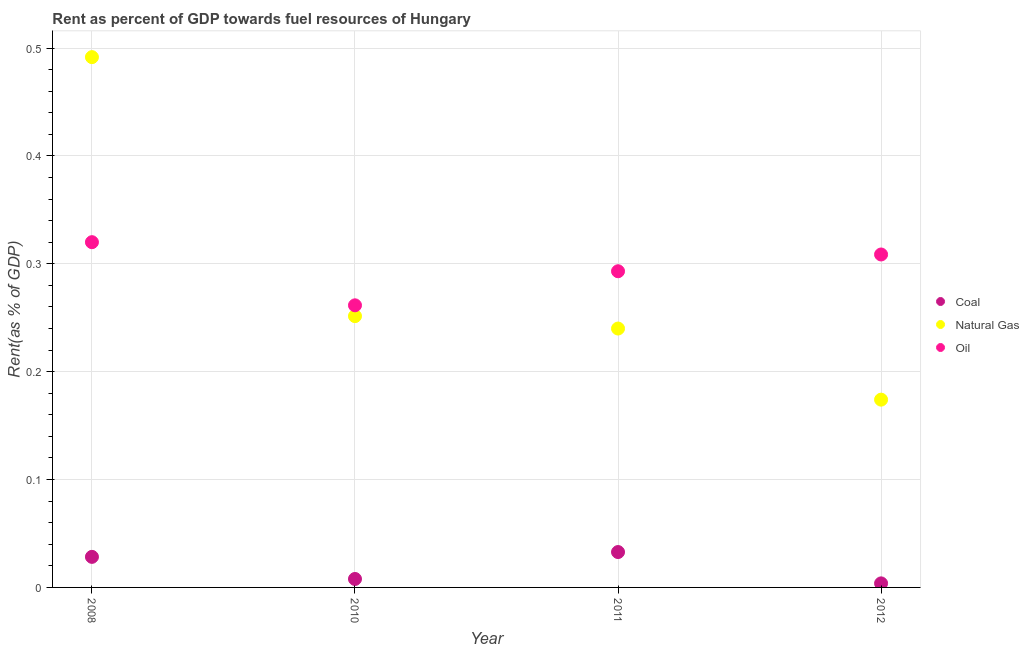Is the number of dotlines equal to the number of legend labels?
Provide a short and direct response. Yes. What is the rent towards oil in 2010?
Make the answer very short. 0.26. Across all years, what is the maximum rent towards coal?
Provide a short and direct response. 0.03. Across all years, what is the minimum rent towards natural gas?
Your answer should be very brief. 0.17. What is the total rent towards coal in the graph?
Keep it short and to the point. 0.07. What is the difference between the rent towards natural gas in 2008 and that in 2012?
Make the answer very short. 0.32. What is the difference between the rent towards coal in 2012 and the rent towards natural gas in 2008?
Your answer should be compact. -0.49. What is the average rent towards natural gas per year?
Your answer should be compact. 0.29. In the year 2011, what is the difference between the rent towards oil and rent towards coal?
Ensure brevity in your answer.  0.26. What is the ratio of the rent towards oil in 2008 to that in 2012?
Offer a terse response. 1.04. Is the rent towards oil in 2011 less than that in 2012?
Make the answer very short. Yes. What is the difference between the highest and the second highest rent towards natural gas?
Provide a succinct answer. 0.24. What is the difference between the highest and the lowest rent towards oil?
Provide a short and direct response. 0.06. Is the rent towards coal strictly less than the rent towards oil over the years?
Your answer should be very brief. Yes. How many dotlines are there?
Ensure brevity in your answer.  3. What is the difference between two consecutive major ticks on the Y-axis?
Give a very brief answer. 0.1. Does the graph contain any zero values?
Your answer should be compact. No. What is the title of the graph?
Your answer should be very brief. Rent as percent of GDP towards fuel resources of Hungary. Does "Natural Gas" appear as one of the legend labels in the graph?
Make the answer very short. Yes. What is the label or title of the Y-axis?
Provide a succinct answer. Rent(as % of GDP). What is the Rent(as % of GDP) of Coal in 2008?
Provide a succinct answer. 0.03. What is the Rent(as % of GDP) of Natural Gas in 2008?
Keep it short and to the point. 0.49. What is the Rent(as % of GDP) in Oil in 2008?
Provide a succinct answer. 0.32. What is the Rent(as % of GDP) of Coal in 2010?
Offer a very short reply. 0.01. What is the Rent(as % of GDP) in Natural Gas in 2010?
Offer a very short reply. 0.25. What is the Rent(as % of GDP) of Oil in 2010?
Your answer should be compact. 0.26. What is the Rent(as % of GDP) of Coal in 2011?
Offer a terse response. 0.03. What is the Rent(as % of GDP) of Natural Gas in 2011?
Your answer should be very brief. 0.24. What is the Rent(as % of GDP) of Oil in 2011?
Make the answer very short. 0.29. What is the Rent(as % of GDP) in Coal in 2012?
Ensure brevity in your answer.  0. What is the Rent(as % of GDP) in Natural Gas in 2012?
Keep it short and to the point. 0.17. What is the Rent(as % of GDP) in Oil in 2012?
Your response must be concise. 0.31. Across all years, what is the maximum Rent(as % of GDP) of Coal?
Give a very brief answer. 0.03. Across all years, what is the maximum Rent(as % of GDP) in Natural Gas?
Give a very brief answer. 0.49. Across all years, what is the maximum Rent(as % of GDP) of Oil?
Your answer should be very brief. 0.32. Across all years, what is the minimum Rent(as % of GDP) in Coal?
Your answer should be very brief. 0. Across all years, what is the minimum Rent(as % of GDP) of Natural Gas?
Your response must be concise. 0.17. Across all years, what is the minimum Rent(as % of GDP) of Oil?
Offer a very short reply. 0.26. What is the total Rent(as % of GDP) of Coal in the graph?
Ensure brevity in your answer.  0.07. What is the total Rent(as % of GDP) of Natural Gas in the graph?
Your answer should be compact. 1.16. What is the total Rent(as % of GDP) of Oil in the graph?
Your answer should be compact. 1.18. What is the difference between the Rent(as % of GDP) in Coal in 2008 and that in 2010?
Offer a terse response. 0.02. What is the difference between the Rent(as % of GDP) in Natural Gas in 2008 and that in 2010?
Keep it short and to the point. 0.24. What is the difference between the Rent(as % of GDP) of Oil in 2008 and that in 2010?
Your answer should be very brief. 0.06. What is the difference between the Rent(as % of GDP) in Coal in 2008 and that in 2011?
Offer a very short reply. -0. What is the difference between the Rent(as % of GDP) in Natural Gas in 2008 and that in 2011?
Your answer should be compact. 0.25. What is the difference between the Rent(as % of GDP) of Oil in 2008 and that in 2011?
Keep it short and to the point. 0.03. What is the difference between the Rent(as % of GDP) in Coal in 2008 and that in 2012?
Make the answer very short. 0.02. What is the difference between the Rent(as % of GDP) in Natural Gas in 2008 and that in 2012?
Offer a very short reply. 0.32. What is the difference between the Rent(as % of GDP) in Oil in 2008 and that in 2012?
Offer a very short reply. 0.01. What is the difference between the Rent(as % of GDP) of Coal in 2010 and that in 2011?
Offer a terse response. -0.03. What is the difference between the Rent(as % of GDP) of Natural Gas in 2010 and that in 2011?
Give a very brief answer. 0.01. What is the difference between the Rent(as % of GDP) in Oil in 2010 and that in 2011?
Make the answer very short. -0.03. What is the difference between the Rent(as % of GDP) of Coal in 2010 and that in 2012?
Your response must be concise. 0. What is the difference between the Rent(as % of GDP) of Natural Gas in 2010 and that in 2012?
Provide a succinct answer. 0.08. What is the difference between the Rent(as % of GDP) in Oil in 2010 and that in 2012?
Your response must be concise. -0.05. What is the difference between the Rent(as % of GDP) in Coal in 2011 and that in 2012?
Provide a short and direct response. 0.03. What is the difference between the Rent(as % of GDP) in Natural Gas in 2011 and that in 2012?
Your answer should be very brief. 0.07. What is the difference between the Rent(as % of GDP) of Oil in 2011 and that in 2012?
Provide a short and direct response. -0.02. What is the difference between the Rent(as % of GDP) in Coal in 2008 and the Rent(as % of GDP) in Natural Gas in 2010?
Your response must be concise. -0.22. What is the difference between the Rent(as % of GDP) of Coal in 2008 and the Rent(as % of GDP) of Oil in 2010?
Make the answer very short. -0.23. What is the difference between the Rent(as % of GDP) in Natural Gas in 2008 and the Rent(as % of GDP) in Oil in 2010?
Provide a succinct answer. 0.23. What is the difference between the Rent(as % of GDP) in Coal in 2008 and the Rent(as % of GDP) in Natural Gas in 2011?
Make the answer very short. -0.21. What is the difference between the Rent(as % of GDP) of Coal in 2008 and the Rent(as % of GDP) of Oil in 2011?
Provide a short and direct response. -0.26. What is the difference between the Rent(as % of GDP) of Natural Gas in 2008 and the Rent(as % of GDP) of Oil in 2011?
Your answer should be very brief. 0.2. What is the difference between the Rent(as % of GDP) of Coal in 2008 and the Rent(as % of GDP) of Natural Gas in 2012?
Give a very brief answer. -0.15. What is the difference between the Rent(as % of GDP) in Coal in 2008 and the Rent(as % of GDP) in Oil in 2012?
Ensure brevity in your answer.  -0.28. What is the difference between the Rent(as % of GDP) of Natural Gas in 2008 and the Rent(as % of GDP) of Oil in 2012?
Offer a terse response. 0.18. What is the difference between the Rent(as % of GDP) of Coal in 2010 and the Rent(as % of GDP) of Natural Gas in 2011?
Your response must be concise. -0.23. What is the difference between the Rent(as % of GDP) of Coal in 2010 and the Rent(as % of GDP) of Oil in 2011?
Offer a very short reply. -0.29. What is the difference between the Rent(as % of GDP) of Natural Gas in 2010 and the Rent(as % of GDP) of Oil in 2011?
Give a very brief answer. -0.04. What is the difference between the Rent(as % of GDP) in Coal in 2010 and the Rent(as % of GDP) in Natural Gas in 2012?
Offer a very short reply. -0.17. What is the difference between the Rent(as % of GDP) of Coal in 2010 and the Rent(as % of GDP) of Oil in 2012?
Make the answer very short. -0.3. What is the difference between the Rent(as % of GDP) of Natural Gas in 2010 and the Rent(as % of GDP) of Oil in 2012?
Make the answer very short. -0.06. What is the difference between the Rent(as % of GDP) in Coal in 2011 and the Rent(as % of GDP) in Natural Gas in 2012?
Provide a short and direct response. -0.14. What is the difference between the Rent(as % of GDP) of Coal in 2011 and the Rent(as % of GDP) of Oil in 2012?
Provide a short and direct response. -0.28. What is the difference between the Rent(as % of GDP) in Natural Gas in 2011 and the Rent(as % of GDP) in Oil in 2012?
Offer a terse response. -0.07. What is the average Rent(as % of GDP) in Coal per year?
Make the answer very short. 0.02. What is the average Rent(as % of GDP) of Natural Gas per year?
Your answer should be very brief. 0.29. What is the average Rent(as % of GDP) in Oil per year?
Make the answer very short. 0.3. In the year 2008, what is the difference between the Rent(as % of GDP) in Coal and Rent(as % of GDP) in Natural Gas?
Your answer should be very brief. -0.46. In the year 2008, what is the difference between the Rent(as % of GDP) in Coal and Rent(as % of GDP) in Oil?
Offer a terse response. -0.29. In the year 2008, what is the difference between the Rent(as % of GDP) of Natural Gas and Rent(as % of GDP) of Oil?
Your response must be concise. 0.17. In the year 2010, what is the difference between the Rent(as % of GDP) in Coal and Rent(as % of GDP) in Natural Gas?
Keep it short and to the point. -0.24. In the year 2010, what is the difference between the Rent(as % of GDP) of Coal and Rent(as % of GDP) of Oil?
Provide a short and direct response. -0.25. In the year 2010, what is the difference between the Rent(as % of GDP) of Natural Gas and Rent(as % of GDP) of Oil?
Give a very brief answer. -0.01. In the year 2011, what is the difference between the Rent(as % of GDP) of Coal and Rent(as % of GDP) of Natural Gas?
Give a very brief answer. -0.21. In the year 2011, what is the difference between the Rent(as % of GDP) in Coal and Rent(as % of GDP) in Oil?
Offer a terse response. -0.26. In the year 2011, what is the difference between the Rent(as % of GDP) in Natural Gas and Rent(as % of GDP) in Oil?
Your answer should be very brief. -0.05. In the year 2012, what is the difference between the Rent(as % of GDP) of Coal and Rent(as % of GDP) of Natural Gas?
Offer a terse response. -0.17. In the year 2012, what is the difference between the Rent(as % of GDP) of Coal and Rent(as % of GDP) of Oil?
Make the answer very short. -0.3. In the year 2012, what is the difference between the Rent(as % of GDP) in Natural Gas and Rent(as % of GDP) in Oil?
Offer a terse response. -0.13. What is the ratio of the Rent(as % of GDP) of Coal in 2008 to that in 2010?
Your answer should be very brief. 3.61. What is the ratio of the Rent(as % of GDP) in Natural Gas in 2008 to that in 2010?
Offer a very short reply. 1.95. What is the ratio of the Rent(as % of GDP) of Oil in 2008 to that in 2010?
Offer a very short reply. 1.22. What is the ratio of the Rent(as % of GDP) in Coal in 2008 to that in 2011?
Offer a terse response. 0.86. What is the ratio of the Rent(as % of GDP) in Natural Gas in 2008 to that in 2011?
Offer a very short reply. 2.05. What is the ratio of the Rent(as % of GDP) of Oil in 2008 to that in 2011?
Your answer should be compact. 1.09. What is the ratio of the Rent(as % of GDP) in Coal in 2008 to that in 2012?
Provide a short and direct response. 7.53. What is the ratio of the Rent(as % of GDP) in Natural Gas in 2008 to that in 2012?
Make the answer very short. 2.82. What is the ratio of the Rent(as % of GDP) in Coal in 2010 to that in 2011?
Offer a very short reply. 0.24. What is the ratio of the Rent(as % of GDP) of Natural Gas in 2010 to that in 2011?
Ensure brevity in your answer.  1.05. What is the ratio of the Rent(as % of GDP) in Oil in 2010 to that in 2011?
Provide a succinct answer. 0.89. What is the ratio of the Rent(as % of GDP) of Coal in 2010 to that in 2012?
Offer a terse response. 2.08. What is the ratio of the Rent(as % of GDP) of Natural Gas in 2010 to that in 2012?
Keep it short and to the point. 1.44. What is the ratio of the Rent(as % of GDP) of Oil in 2010 to that in 2012?
Provide a short and direct response. 0.85. What is the ratio of the Rent(as % of GDP) in Coal in 2011 to that in 2012?
Keep it short and to the point. 8.72. What is the ratio of the Rent(as % of GDP) of Natural Gas in 2011 to that in 2012?
Make the answer very short. 1.38. What is the ratio of the Rent(as % of GDP) in Oil in 2011 to that in 2012?
Your answer should be very brief. 0.95. What is the difference between the highest and the second highest Rent(as % of GDP) of Coal?
Provide a succinct answer. 0. What is the difference between the highest and the second highest Rent(as % of GDP) of Natural Gas?
Keep it short and to the point. 0.24. What is the difference between the highest and the second highest Rent(as % of GDP) of Oil?
Give a very brief answer. 0.01. What is the difference between the highest and the lowest Rent(as % of GDP) of Coal?
Provide a short and direct response. 0.03. What is the difference between the highest and the lowest Rent(as % of GDP) of Natural Gas?
Make the answer very short. 0.32. What is the difference between the highest and the lowest Rent(as % of GDP) in Oil?
Offer a very short reply. 0.06. 